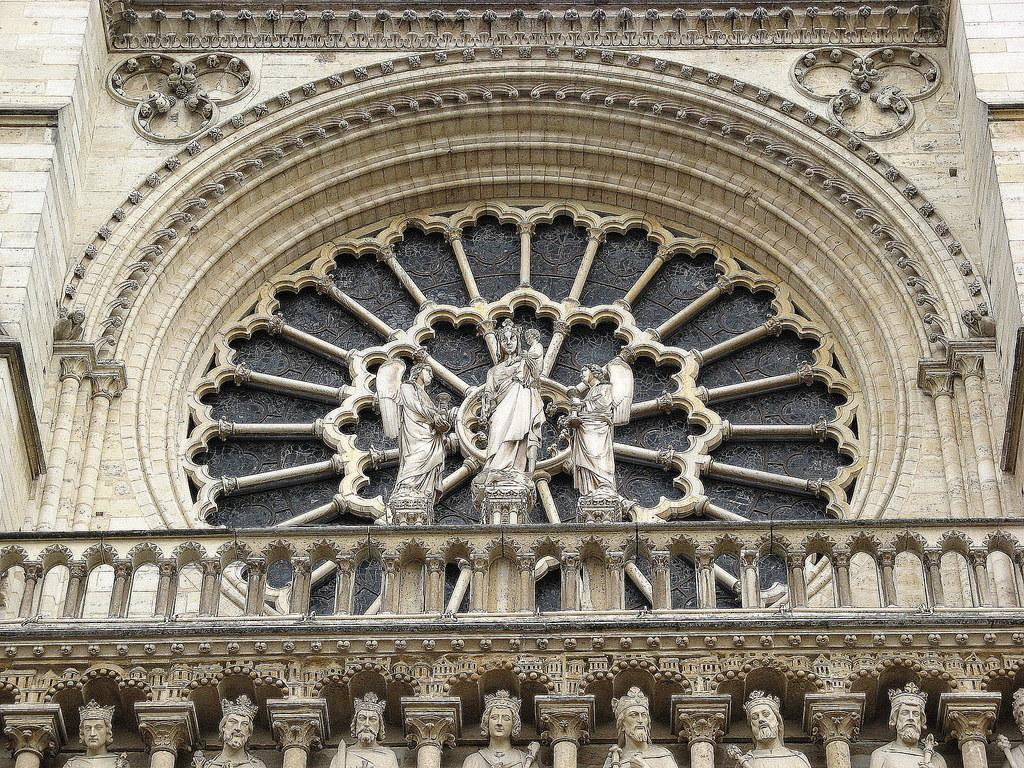What is the main subject of the image? The main subject of the image is a statue of persons. What type of fencing is present in the image? There is a concrete fencing in the image. Can you describe the base of the monument? At the bottom of the monument, there are multiple statues of men and women. What is located at the top of the image? There is a monument at the top of the image. How many snakes are coiled around the monument in the image? There are no snakes present in the image; the monument and statues are the main subjects. What type of thumb is visible on the statue's hand in the image? There is no thumb visible on the statue's hand in the image, as the statue is not depicted in a way that shows individual fingers. 